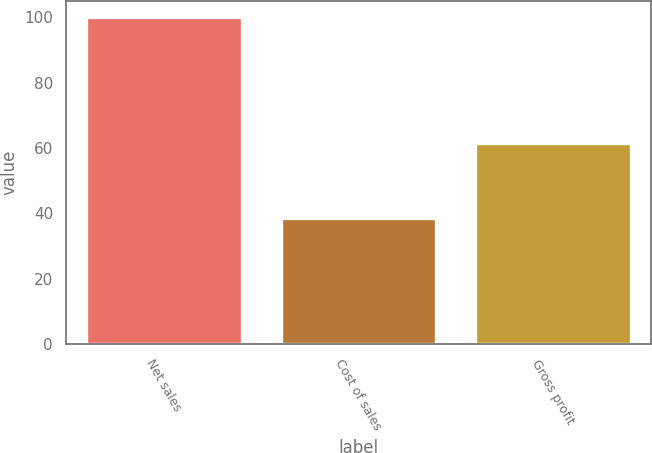Convert chart to OTSL. <chart><loc_0><loc_0><loc_500><loc_500><bar_chart><fcel>Net sales<fcel>Cost of sales<fcel>Gross profit<nl><fcel>100<fcel>38.5<fcel>61.5<nl></chart> 